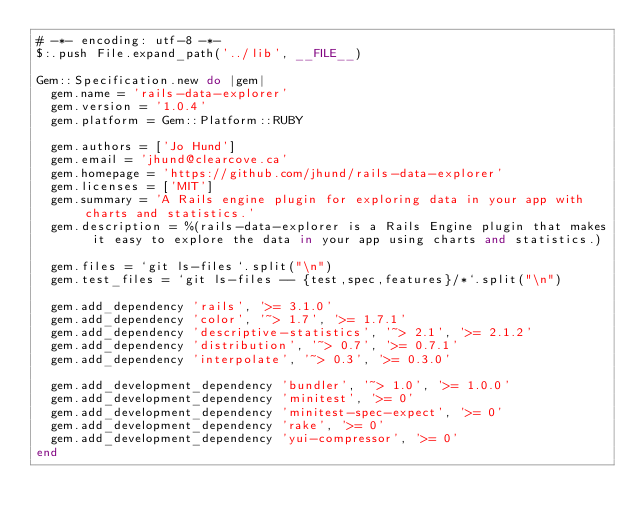<code> <loc_0><loc_0><loc_500><loc_500><_Ruby_># -*- encoding: utf-8 -*-
$:.push File.expand_path('../lib', __FILE__)

Gem::Specification.new do |gem|
  gem.name = 'rails-data-explorer'
  gem.version = '1.0.4'
  gem.platform = Gem::Platform::RUBY

  gem.authors = ['Jo Hund']
  gem.email = 'jhund@clearcove.ca'
  gem.homepage = 'https://github.com/jhund/rails-data-explorer'
  gem.licenses = ['MIT']
  gem.summary = 'A Rails engine plugin for exploring data in your app with charts and statistics.'
  gem.description = %(rails-data-explorer is a Rails Engine plugin that makes it easy to explore the data in your app using charts and statistics.)

  gem.files = `git ls-files`.split("\n")
  gem.test_files = `git ls-files -- {test,spec,features}/*`.split("\n")

  gem.add_dependency 'rails', '>= 3.1.0'
  gem.add_dependency 'color', '~> 1.7', '>= 1.7.1'
  gem.add_dependency 'descriptive-statistics', '~> 2.1', '>= 2.1.2'
  gem.add_dependency 'distribution', '~> 0.7', '>= 0.7.1'
  gem.add_dependency 'interpolate', '~> 0.3', '>= 0.3.0'

  gem.add_development_dependency 'bundler', '~> 1.0', '>= 1.0.0'
  gem.add_development_dependency 'minitest', '>= 0'
  gem.add_development_dependency 'minitest-spec-expect', '>= 0'
  gem.add_development_dependency 'rake', '>= 0'
  gem.add_development_dependency 'yui-compressor', '>= 0'
end
</code> 